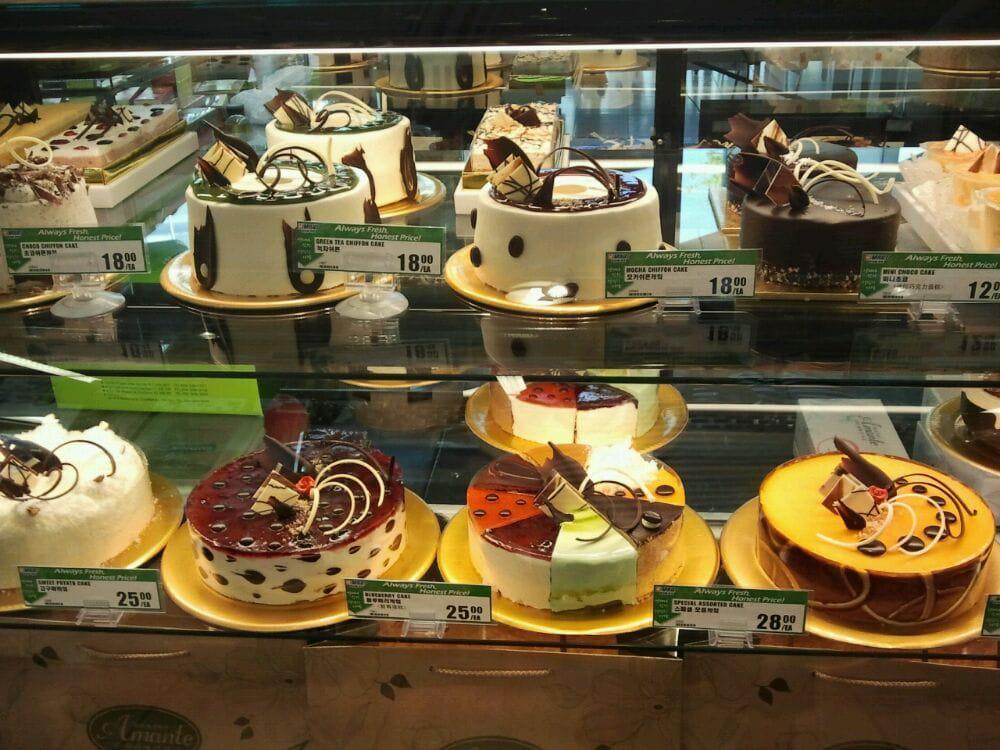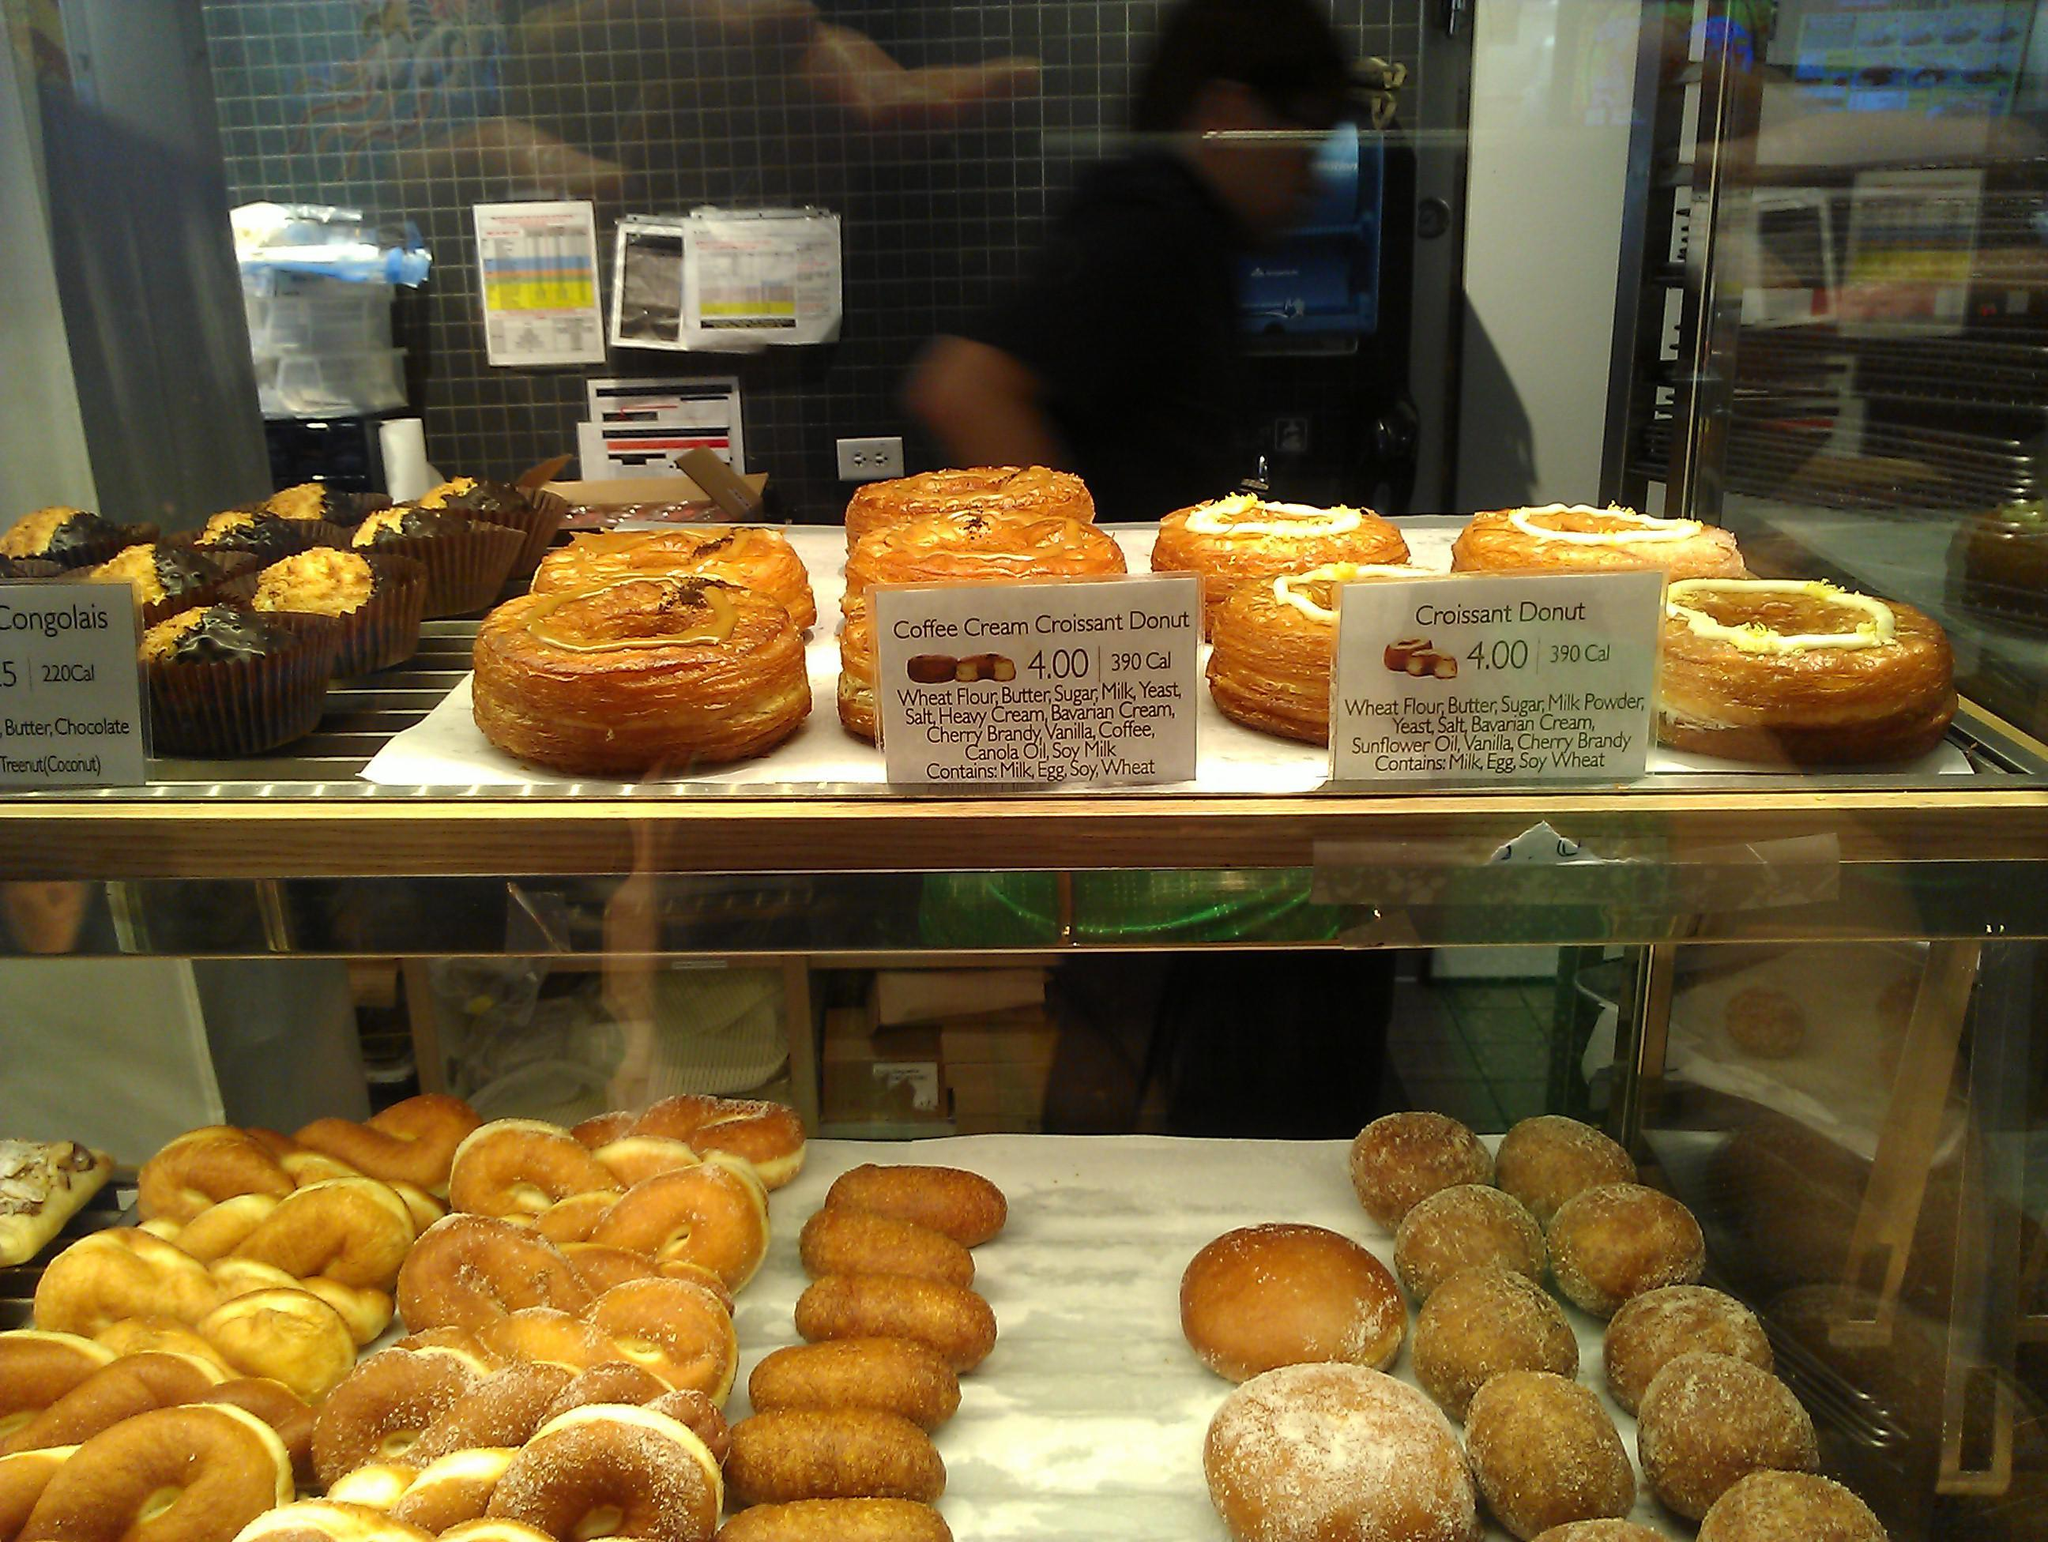The first image is the image on the left, the second image is the image on the right. Analyze the images presented: Is the assertion "Some items are wrapped in clear plastic." valid? Answer yes or no. No. The first image is the image on the left, the second image is the image on the right. Examine the images to the left and right. Is the description "The left image shows decorated cakes on at least the top row of a glass case, and the decorations include upright chocolate shapes." accurate? Answer yes or no. Yes. 